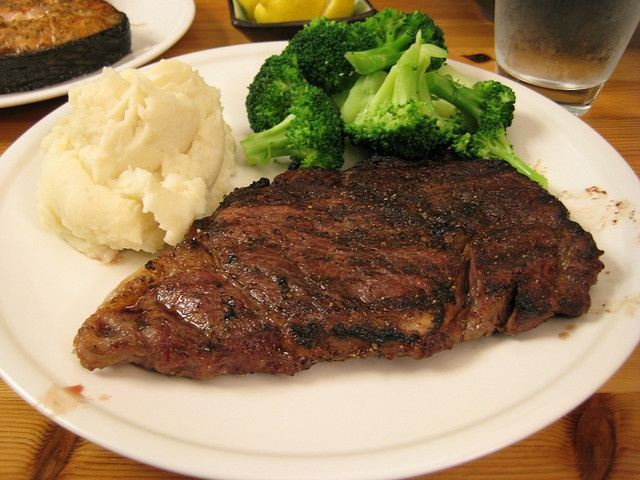Describe the objects in this image and their specific colors. I can see broccoli in olive, darkgreen, and black tones, cup in olive, black, and maroon tones, broccoli in olive and khaki tones, and broccoli in olive, darkgreen, black, and green tones in this image. 